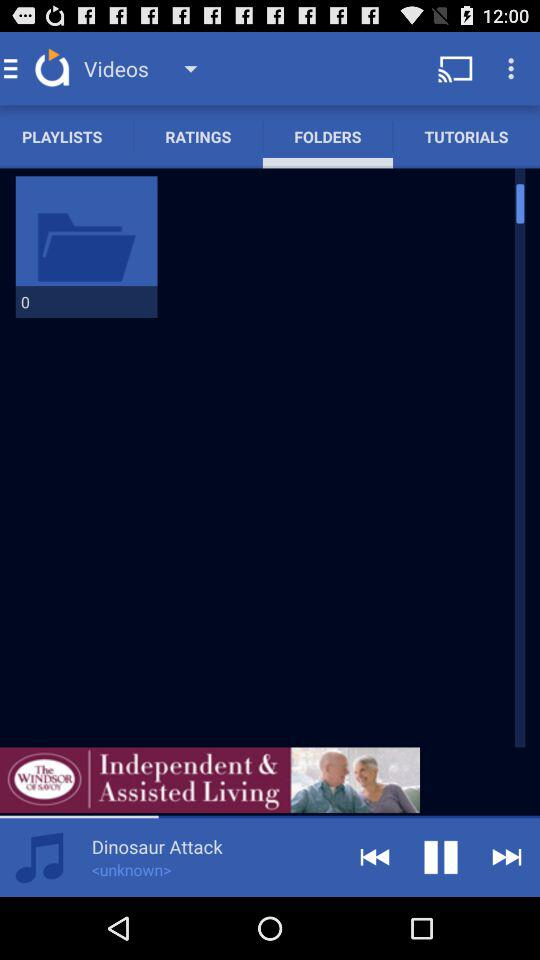Which devices can the application be cast to?
When the provided information is insufficient, respond with <no answer>. <no answer> 